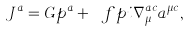Convert formula to latex. <formula><loc_0><loc_0><loc_500><loc_500>J ^ { a } = G p ^ { a } + \ f p i \nabla ^ { a c } _ { \mu } a ^ { \mu c } ,</formula> 